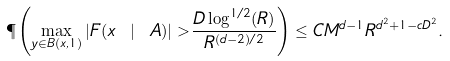<formula> <loc_0><loc_0><loc_500><loc_500>\P \left ( \max _ { y \in B ( x , 1 ) } | F ( x \ | \ A ) | > \frac { D \log ^ { 1 / 2 } ( R ) } { R ^ { ( d - 2 ) / 2 } } \right ) \leq C M ^ { d - 1 } R ^ { d ^ { 2 } + 1 - c D ^ { 2 } } .</formula> 